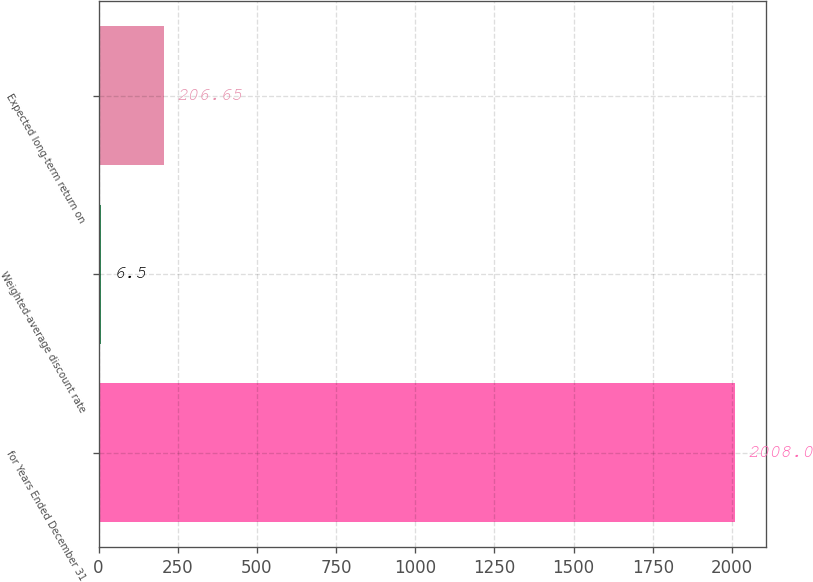<chart> <loc_0><loc_0><loc_500><loc_500><bar_chart><fcel>for Years Ended December 31<fcel>Weighted-average discount rate<fcel>Expected long-term return on<nl><fcel>2008<fcel>6.5<fcel>206.65<nl></chart> 